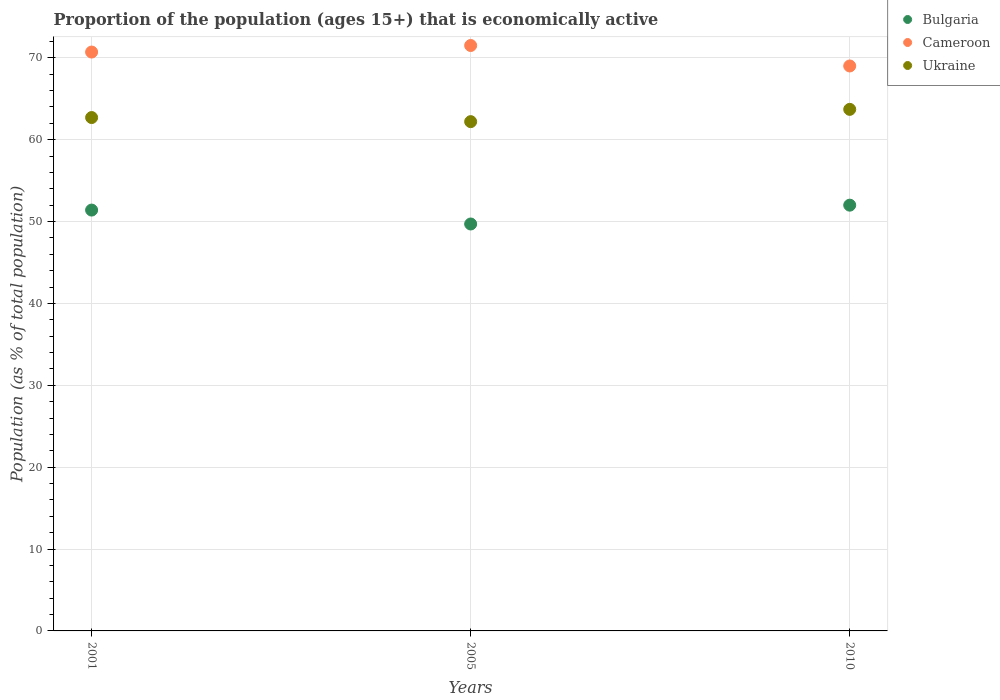Is the number of dotlines equal to the number of legend labels?
Ensure brevity in your answer.  Yes. What is the proportion of the population that is economically active in Bulgaria in 2001?
Your response must be concise. 51.4. Across all years, what is the maximum proportion of the population that is economically active in Bulgaria?
Provide a succinct answer. 52. Across all years, what is the minimum proportion of the population that is economically active in Bulgaria?
Keep it short and to the point. 49.7. In which year was the proportion of the population that is economically active in Ukraine maximum?
Your answer should be compact. 2010. In which year was the proportion of the population that is economically active in Cameroon minimum?
Provide a succinct answer. 2010. What is the total proportion of the population that is economically active in Bulgaria in the graph?
Give a very brief answer. 153.1. What is the average proportion of the population that is economically active in Ukraine per year?
Ensure brevity in your answer.  62.87. In the year 2001, what is the difference between the proportion of the population that is economically active in Cameroon and proportion of the population that is economically active in Ukraine?
Your answer should be very brief. 8. What is the ratio of the proportion of the population that is economically active in Ukraine in 2001 to that in 2005?
Offer a terse response. 1.01. Is the proportion of the population that is economically active in Cameroon in 2001 less than that in 2005?
Provide a short and direct response. Yes. Is the difference between the proportion of the population that is economically active in Cameroon in 2001 and 2005 greater than the difference between the proportion of the population that is economically active in Ukraine in 2001 and 2005?
Provide a short and direct response. No. What is the difference between the highest and the second highest proportion of the population that is economically active in Ukraine?
Offer a very short reply. 1. Is it the case that in every year, the sum of the proportion of the population that is economically active in Cameroon and proportion of the population that is economically active in Ukraine  is greater than the proportion of the population that is economically active in Bulgaria?
Offer a terse response. Yes. Is the proportion of the population that is economically active in Ukraine strictly greater than the proportion of the population that is economically active in Bulgaria over the years?
Your response must be concise. Yes. Is the proportion of the population that is economically active in Bulgaria strictly less than the proportion of the population that is economically active in Cameroon over the years?
Your answer should be compact. Yes. What is the difference between two consecutive major ticks on the Y-axis?
Give a very brief answer. 10. Are the values on the major ticks of Y-axis written in scientific E-notation?
Your response must be concise. No. Does the graph contain grids?
Keep it short and to the point. Yes. What is the title of the graph?
Make the answer very short. Proportion of the population (ages 15+) that is economically active. What is the label or title of the X-axis?
Make the answer very short. Years. What is the label or title of the Y-axis?
Ensure brevity in your answer.  Population (as % of total population). What is the Population (as % of total population) of Bulgaria in 2001?
Give a very brief answer. 51.4. What is the Population (as % of total population) of Cameroon in 2001?
Your response must be concise. 70.7. What is the Population (as % of total population) of Ukraine in 2001?
Offer a very short reply. 62.7. What is the Population (as % of total population) in Bulgaria in 2005?
Keep it short and to the point. 49.7. What is the Population (as % of total population) in Cameroon in 2005?
Your answer should be compact. 71.5. What is the Population (as % of total population) of Ukraine in 2005?
Provide a short and direct response. 62.2. What is the Population (as % of total population) in Cameroon in 2010?
Provide a succinct answer. 69. What is the Population (as % of total population) of Ukraine in 2010?
Your answer should be very brief. 63.7. Across all years, what is the maximum Population (as % of total population) in Bulgaria?
Provide a short and direct response. 52. Across all years, what is the maximum Population (as % of total population) of Cameroon?
Your answer should be compact. 71.5. Across all years, what is the maximum Population (as % of total population) in Ukraine?
Make the answer very short. 63.7. Across all years, what is the minimum Population (as % of total population) in Bulgaria?
Make the answer very short. 49.7. Across all years, what is the minimum Population (as % of total population) in Ukraine?
Provide a succinct answer. 62.2. What is the total Population (as % of total population) of Bulgaria in the graph?
Your response must be concise. 153.1. What is the total Population (as % of total population) of Cameroon in the graph?
Your answer should be compact. 211.2. What is the total Population (as % of total population) in Ukraine in the graph?
Offer a terse response. 188.6. What is the difference between the Population (as % of total population) in Cameroon in 2001 and that in 2005?
Ensure brevity in your answer.  -0.8. What is the difference between the Population (as % of total population) in Bulgaria in 2001 and that in 2010?
Keep it short and to the point. -0.6. What is the difference between the Population (as % of total population) of Cameroon in 2001 and that in 2010?
Make the answer very short. 1.7. What is the difference between the Population (as % of total population) of Bulgaria in 2001 and the Population (as % of total population) of Cameroon in 2005?
Keep it short and to the point. -20.1. What is the difference between the Population (as % of total population) of Bulgaria in 2001 and the Population (as % of total population) of Cameroon in 2010?
Make the answer very short. -17.6. What is the difference between the Population (as % of total population) of Cameroon in 2001 and the Population (as % of total population) of Ukraine in 2010?
Keep it short and to the point. 7. What is the difference between the Population (as % of total population) of Bulgaria in 2005 and the Population (as % of total population) of Cameroon in 2010?
Make the answer very short. -19.3. What is the difference between the Population (as % of total population) in Cameroon in 2005 and the Population (as % of total population) in Ukraine in 2010?
Keep it short and to the point. 7.8. What is the average Population (as % of total population) in Bulgaria per year?
Your answer should be very brief. 51.03. What is the average Population (as % of total population) of Cameroon per year?
Give a very brief answer. 70.4. What is the average Population (as % of total population) of Ukraine per year?
Provide a short and direct response. 62.87. In the year 2001, what is the difference between the Population (as % of total population) in Bulgaria and Population (as % of total population) in Cameroon?
Offer a very short reply. -19.3. In the year 2001, what is the difference between the Population (as % of total population) of Cameroon and Population (as % of total population) of Ukraine?
Your response must be concise. 8. In the year 2005, what is the difference between the Population (as % of total population) of Bulgaria and Population (as % of total population) of Cameroon?
Keep it short and to the point. -21.8. In the year 2005, what is the difference between the Population (as % of total population) in Bulgaria and Population (as % of total population) in Ukraine?
Your answer should be compact. -12.5. In the year 2010, what is the difference between the Population (as % of total population) in Bulgaria and Population (as % of total population) in Cameroon?
Ensure brevity in your answer.  -17. What is the ratio of the Population (as % of total population) of Bulgaria in 2001 to that in 2005?
Make the answer very short. 1.03. What is the ratio of the Population (as % of total population) of Bulgaria in 2001 to that in 2010?
Keep it short and to the point. 0.99. What is the ratio of the Population (as % of total population) in Cameroon in 2001 to that in 2010?
Offer a very short reply. 1.02. What is the ratio of the Population (as % of total population) in Ukraine in 2001 to that in 2010?
Keep it short and to the point. 0.98. What is the ratio of the Population (as % of total population) in Bulgaria in 2005 to that in 2010?
Provide a succinct answer. 0.96. What is the ratio of the Population (as % of total population) in Cameroon in 2005 to that in 2010?
Make the answer very short. 1.04. What is the ratio of the Population (as % of total population) of Ukraine in 2005 to that in 2010?
Offer a very short reply. 0.98. What is the difference between the highest and the second highest Population (as % of total population) of Cameroon?
Your answer should be very brief. 0.8. What is the difference between the highest and the lowest Population (as % of total population) of Bulgaria?
Make the answer very short. 2.3. 